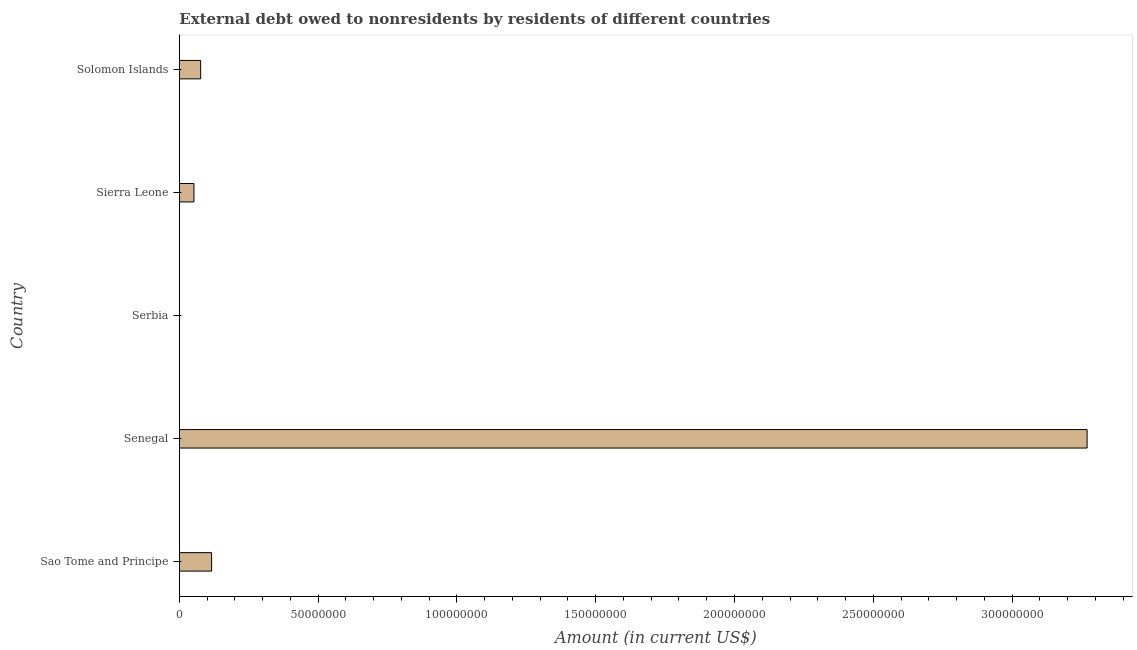Does the graph contain any zero values?
Make the answer very short. Yes. Does the graph contain grids?
Provide a succinct answer. No. What is the title of the graph?
Make the answer very short. External debt owed to nonresidents by residents of different countries. What is the debt in Senegal?
Provide a succinct answer. 3.27e+08. Across all countries, what is the maximum debt?
Offer a terse response. 3.27e+08. Across all countries, what is the minimum debt?
Make the answer very short. 0. In which country was the debt maximum?
Provide a short and direct response. Senegal. What is the sum of the debt?
Offer a terse response. 3.52e+08. What is the difference between the debt in Senegal and Solomon Islands?
Provide a succinct answer. 3.19e+08. What is the average debt per country?
Provide a short and direct response. 7.03e+07. What is the median debt?
Provide a short and direct response. 7.65e+06. In how many countries, is the debt greater than 210000000 US$?
Ensure brevity in your answer.  1. What is the ratio of the debt in Sao Tome and Principe to that in Solomon Islands?
Provide a short and direct response. 1.51. Is the difference between the debt in Sao Tome and Principe and Senegal greater than the difference between any two countries?
Offer a terse response. No. What is the difference between the highest and the second highest debt?
Offer a terse response. 3.15e+08. What is the difference between the highest and the lowest debt?
Keep it short and to the point. 3.27e+08. In how many countries, is the debt greater than the average debt taken over all countries?
Offer a terse response. 1. How many bars are there?
Your answer should be compact. 4. Are all the bars in the graph horizontal?
Keep it short and to the point. Yes. What is the difference between two consecutive major ticks on the X-axis?
Your answer should be very brief. 5.00e+07. Are the values on the major ticks of X-axis written in scientific E-notation?
Provide a short and direct response. No. What is the Amount (in current US$) of Sao Tome and Principe?
Your answer should be compact. 1.16e+07. What is the Amount (in current US$) in Senegal?
Offer a very short reply. 3.27e+08. What is the Amount (in current US$) in Sierra Leone?
Offer a terse response. 5.24e+06. What is the Amount (in current US$) in Solomon Islands?
Ensure brevity in your answer.  7.65e+06. What is the difference between the Amount (in current US$) in Sao Tome and Principe and Senegal?
Your answer should be compact. -3.15e+08. What is the difference between the Amount (in current US$) in Sao Tome and Principe and Sierra Leone?
Keep it short and to the point. 6.35e+06. What is the difference between the Amount (in current US$) in Sao Tome and Principe and Solomon Islands?
Your answer should be compact. 3.94e+06. What is the difference between the Amount (in current US$) in Senegal and Sierra Leone?
Offer a terse response. 3.22e+08. What is the difference between the Amount (in current US$) in Senegal and Solomon Islands?
Your response must be concise. 3.19e+08. What is the difference between the Amount (in current US$) in Sierra Leone and Solomon Islands?
Offer a terse response. -2.41e+06. What is the ratio of the Amount (in current US$) in Sao Tome and Principe to that in Senegal?
Give a very brief answer. 0.04. What is the ratio of the Amount (in current US$) in Sao Tome and Principe to that in Sierra Leone?
Keep it short and to the point. 2.21. What is the ratio of the Amount (in current US$) in Sao Tome and Principe to that in Solomon Islands?
Provide a short and direct response. 1.51. What is the ratio of the Amount (in current US$) in Senegal to that in Sierra Leone?
Provide a succinct answer. 62.4. What is the ratio of the Amount (in current US$) in Senegal to that in Solomon Islands?
Provide a short and direct response. 42.73. What is the ratio of the Amount (in current US$) in Sierra Leone to that in Solomon Islands?
Keep it short and to the point. 0.69. 